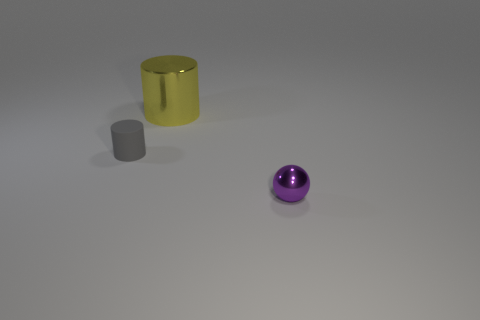Add 1 tiny shiny things. How many objects exist? 4 Subtract all balls. How many objects are left? 2 Add 2 large cyan metal cylinders. How many large cyan metal cylinders exist? 2 Subtract 1 yellow cylinders. How many objects are left? 2 Subtract all blue cylinders. Subtract all balls. How many objects are left? 2 Add 1 tiny purple spheres. How many tiny purple spheres are left? 2 